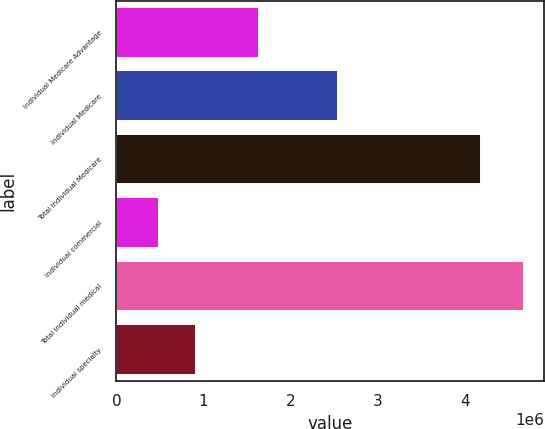<chart> <loc_0><loc_0><loc_500><loc_500><bar_chart><fcel>Individual Medicare Advantage<fcel>Individual Medicare<fcel>Total individual Medicare<fcel>Individual commercial<fcel>Total individual medical<fcel>Individual specialty<nl><fcel>1.6403e+06<fcel>2.5404e+06<fcel>4.1807e+06<fcel>493200<fcel>4.6739e+06<fcel>911270<nl></chart> 